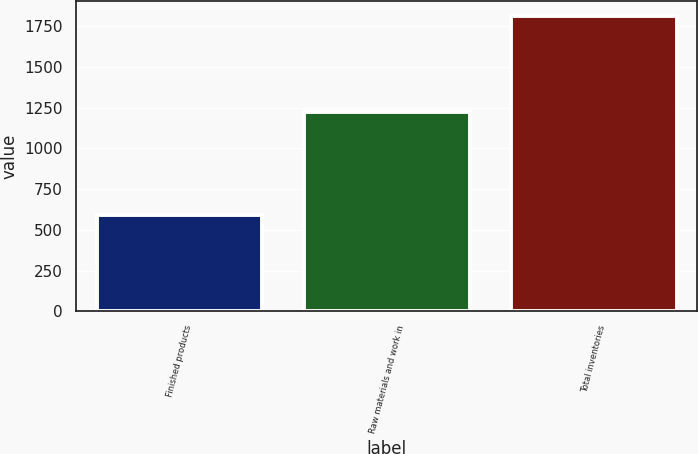<chart> <loc_0><loc_0><loc_500><loc_500><bar_chart><fcel>Finished products<fcel>Raw materials and work in<fcel>Total inventories<nl><fcel>592<fcel>1221<fcel>1813<nl></chart> 